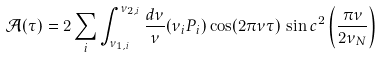Convert formula to latex. <formula><loc_0><loc_0><loc_500><loc_500>\mathcal { A } ( \tau ) = 2 \sum _ { i } \int _ { \nu _ { 1 , i } } ^ { \nu _ { 2 , i } } \frac { d \nu } { \nu } ( \nu _ { i } P _ { i } ) \cos ( 2 \pi \nu \tau ) \, \sin c ^ { 2 } \left ( \frac { \pi \nu } { 2 \nu _ { N } } \right )</formula> 